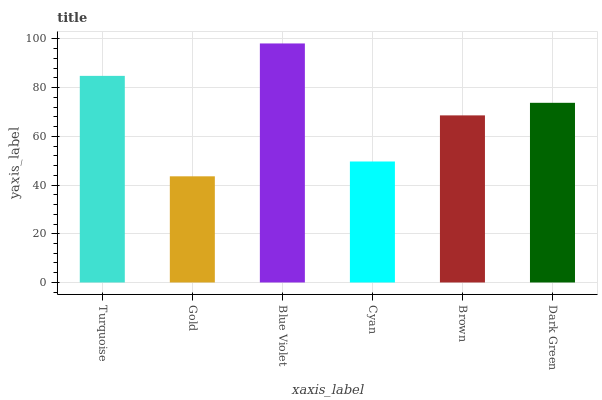Is Gold the minimum?
Answer yes or no. Yes. Is Blue Violet the maximum?
Answer yes or no. Yes. Is Blue Violet the minimum?
Answer yes or no. No. Is Gold the maximum?
Answer yes or no. No. Is Blue Violet greater than Gold?
Answer yes or no. Yes. Is Gold less than Blue Violet?
Answer yes or no. Yes. Is Gold greater than Blue Violet?
Answer yes or no. No. Is Blue Violet less than Gold?
Answer yes or no. No. Is Dark Green the high median?
Answer yes or no. Yes. Is Brown the low median?
Answer yes or no. Yes. Is Blue Violet the high median?
Answer yes or no. No. Is Gold the low median?
Answer yes or no. No. 